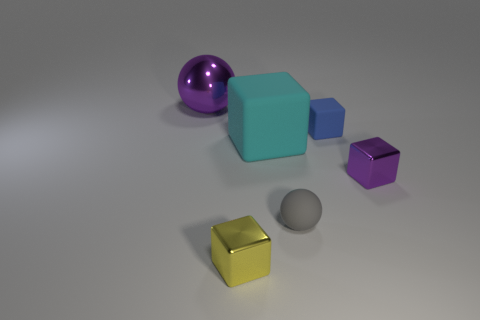Subtract all small cubes. How many cubes are left? 1 Subtract all cyan cubes. How many cubes are left? 3 Add 3 spheres. How many objects exist? 9 Subtract 1 blocks. How many blocks are left? 3 Subtract all big cyan matte cubes. Subtract all tiny gray balls. How many objects are left? 4 Add 1 small metallic things. How many small metallic things are left? 3 Add 6 yellow cubes. How many yellow cubes exist? 7 Subtract 0 green balls. How many objects are left? 6 Subtract all spheres. How many objects are left? 4 Subtract all yellow cubes. Subtract all blue balls. How many cubes are left? 3 